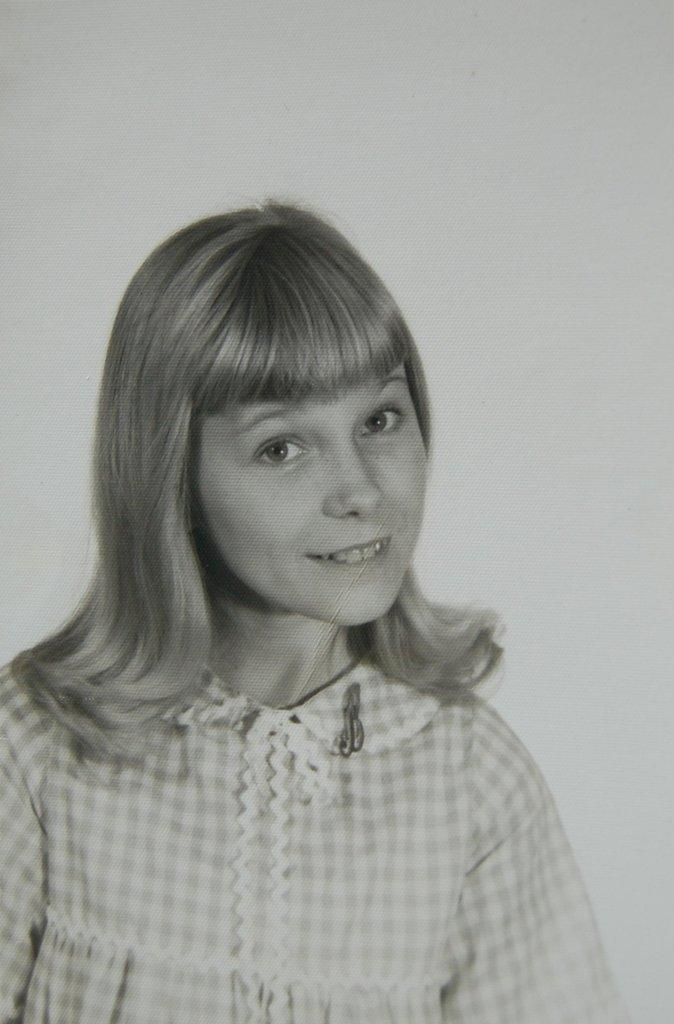What is the color scheme of the image? The image is black and white. Can you describe the main subject of the image? There is a girl in the image. What type of soap is the girl using in the image? There is no soap present in the image, as it is a black and white image of a girl. 